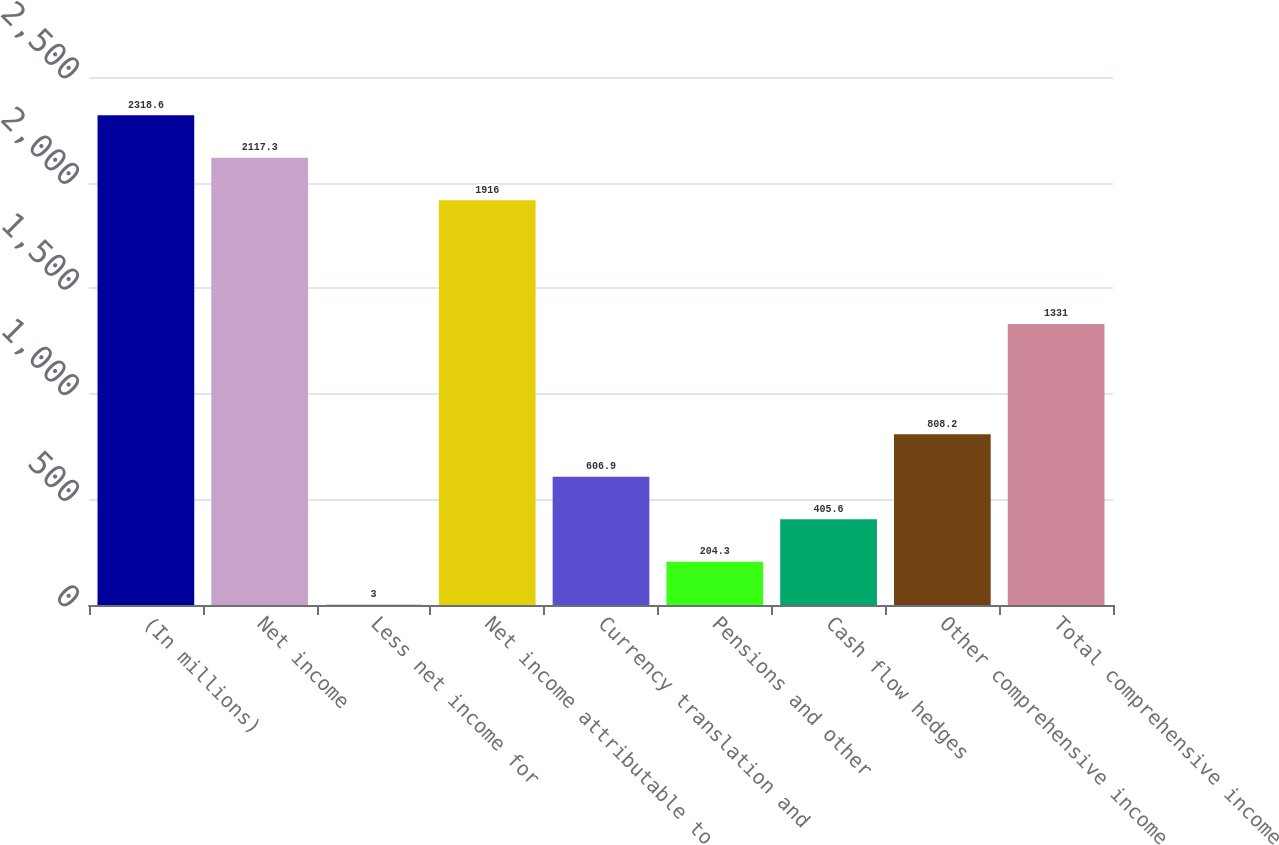<chart> <loc_0><loc_0><loc_500><loc_500><bar_chart><fcel>(In millions)<fcel>Net income<fcel>Less net income for<fcel>Net income attributable to<fcel>Currency translation and<fcel>Pensions and other<fcel>Cash flow hedges<fcel>Other comprehensive income<fcel>Total comprehensive income<nl><fcel>2318.6<fcel>2117.3<fcel>3<fcel>1916<fcel>606.9<fcel>204.3<fcel>405.6<fcel>808.2<fcel>1331<nl></chart> 